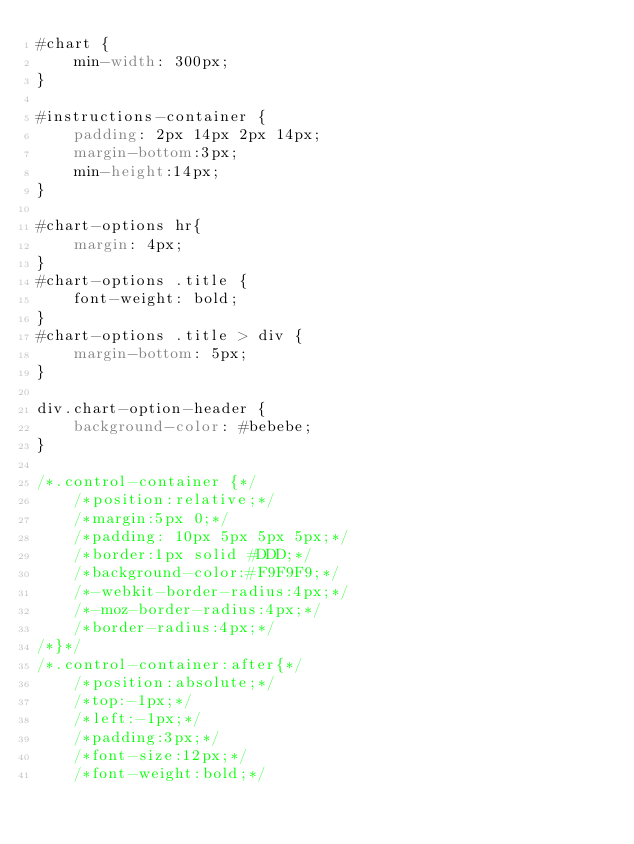Convert code to text. <code><loc_0><loc_0><loc_500><loc_500><_CSS_>#chart {
    min-width: 300px;
}

#instructions-container {
    padding: 2px 14px 2px 14px;
    margin-bottom:3px;
    min-height:14px;
}

#chart-options hr{
    margin: 4px;
}
#chart-options .title {
    font-weight: bold;
}
#chart-options .title > div {
    margin-bottom: 5px;
}

div.chart-option-header {
    background-color: #bebebe;
}

/*.control-container {*/
    /*position:relative;*/
    /*margin:5px 0;*/
    /*padding: 10px 5px 5px 5px;*/
    /*border:1px solid #DDD;*/
    /*background-color:#F9F9F9;*/
    /*-webkit-border-radius:4px;*/
    /*-moz-border-radius:4px;*/
    /*border-radius:4px;*/
/*}*/
/*.control-container:after{*/
    /*position:absolute;*/
    /*top:-1px;*/
    /*left:-1px;*/
    /*padding:3px;*/
    /*font-size:12px;*/
    /*font-weight:bold;*/</code> 